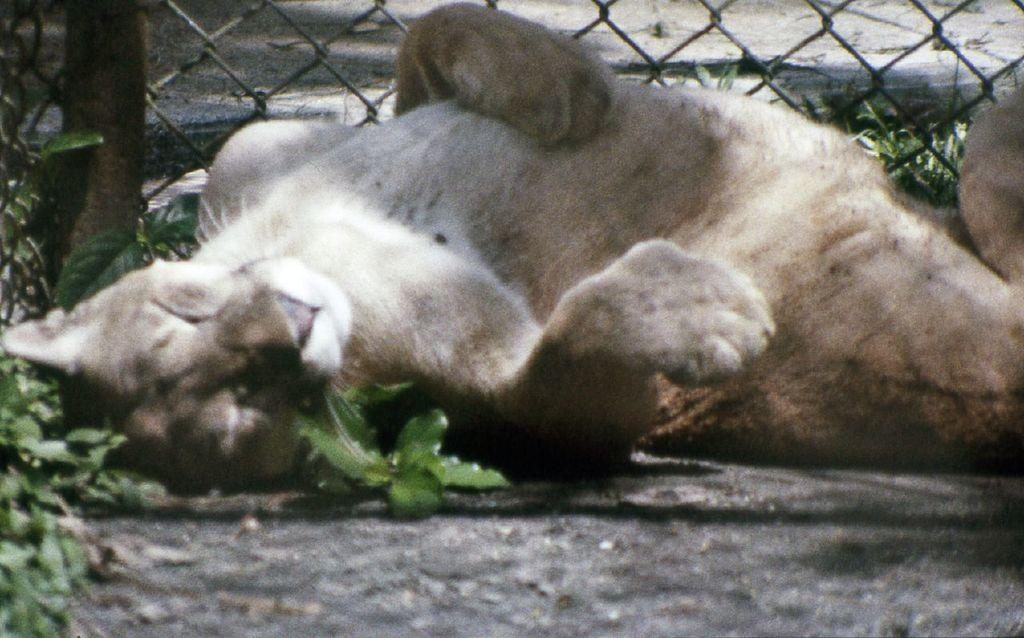What animal can be seen in the image? There is a cat in the image. What is the cat doing in the image? The cat is laying on the road. What can be seen in the background of the image? There is fencing and grass in the background of the image. What type of linen is being used to control the cat's toes in the image? There is no linen or control of toes present in the image; it simply shows a cat laying on the road. 